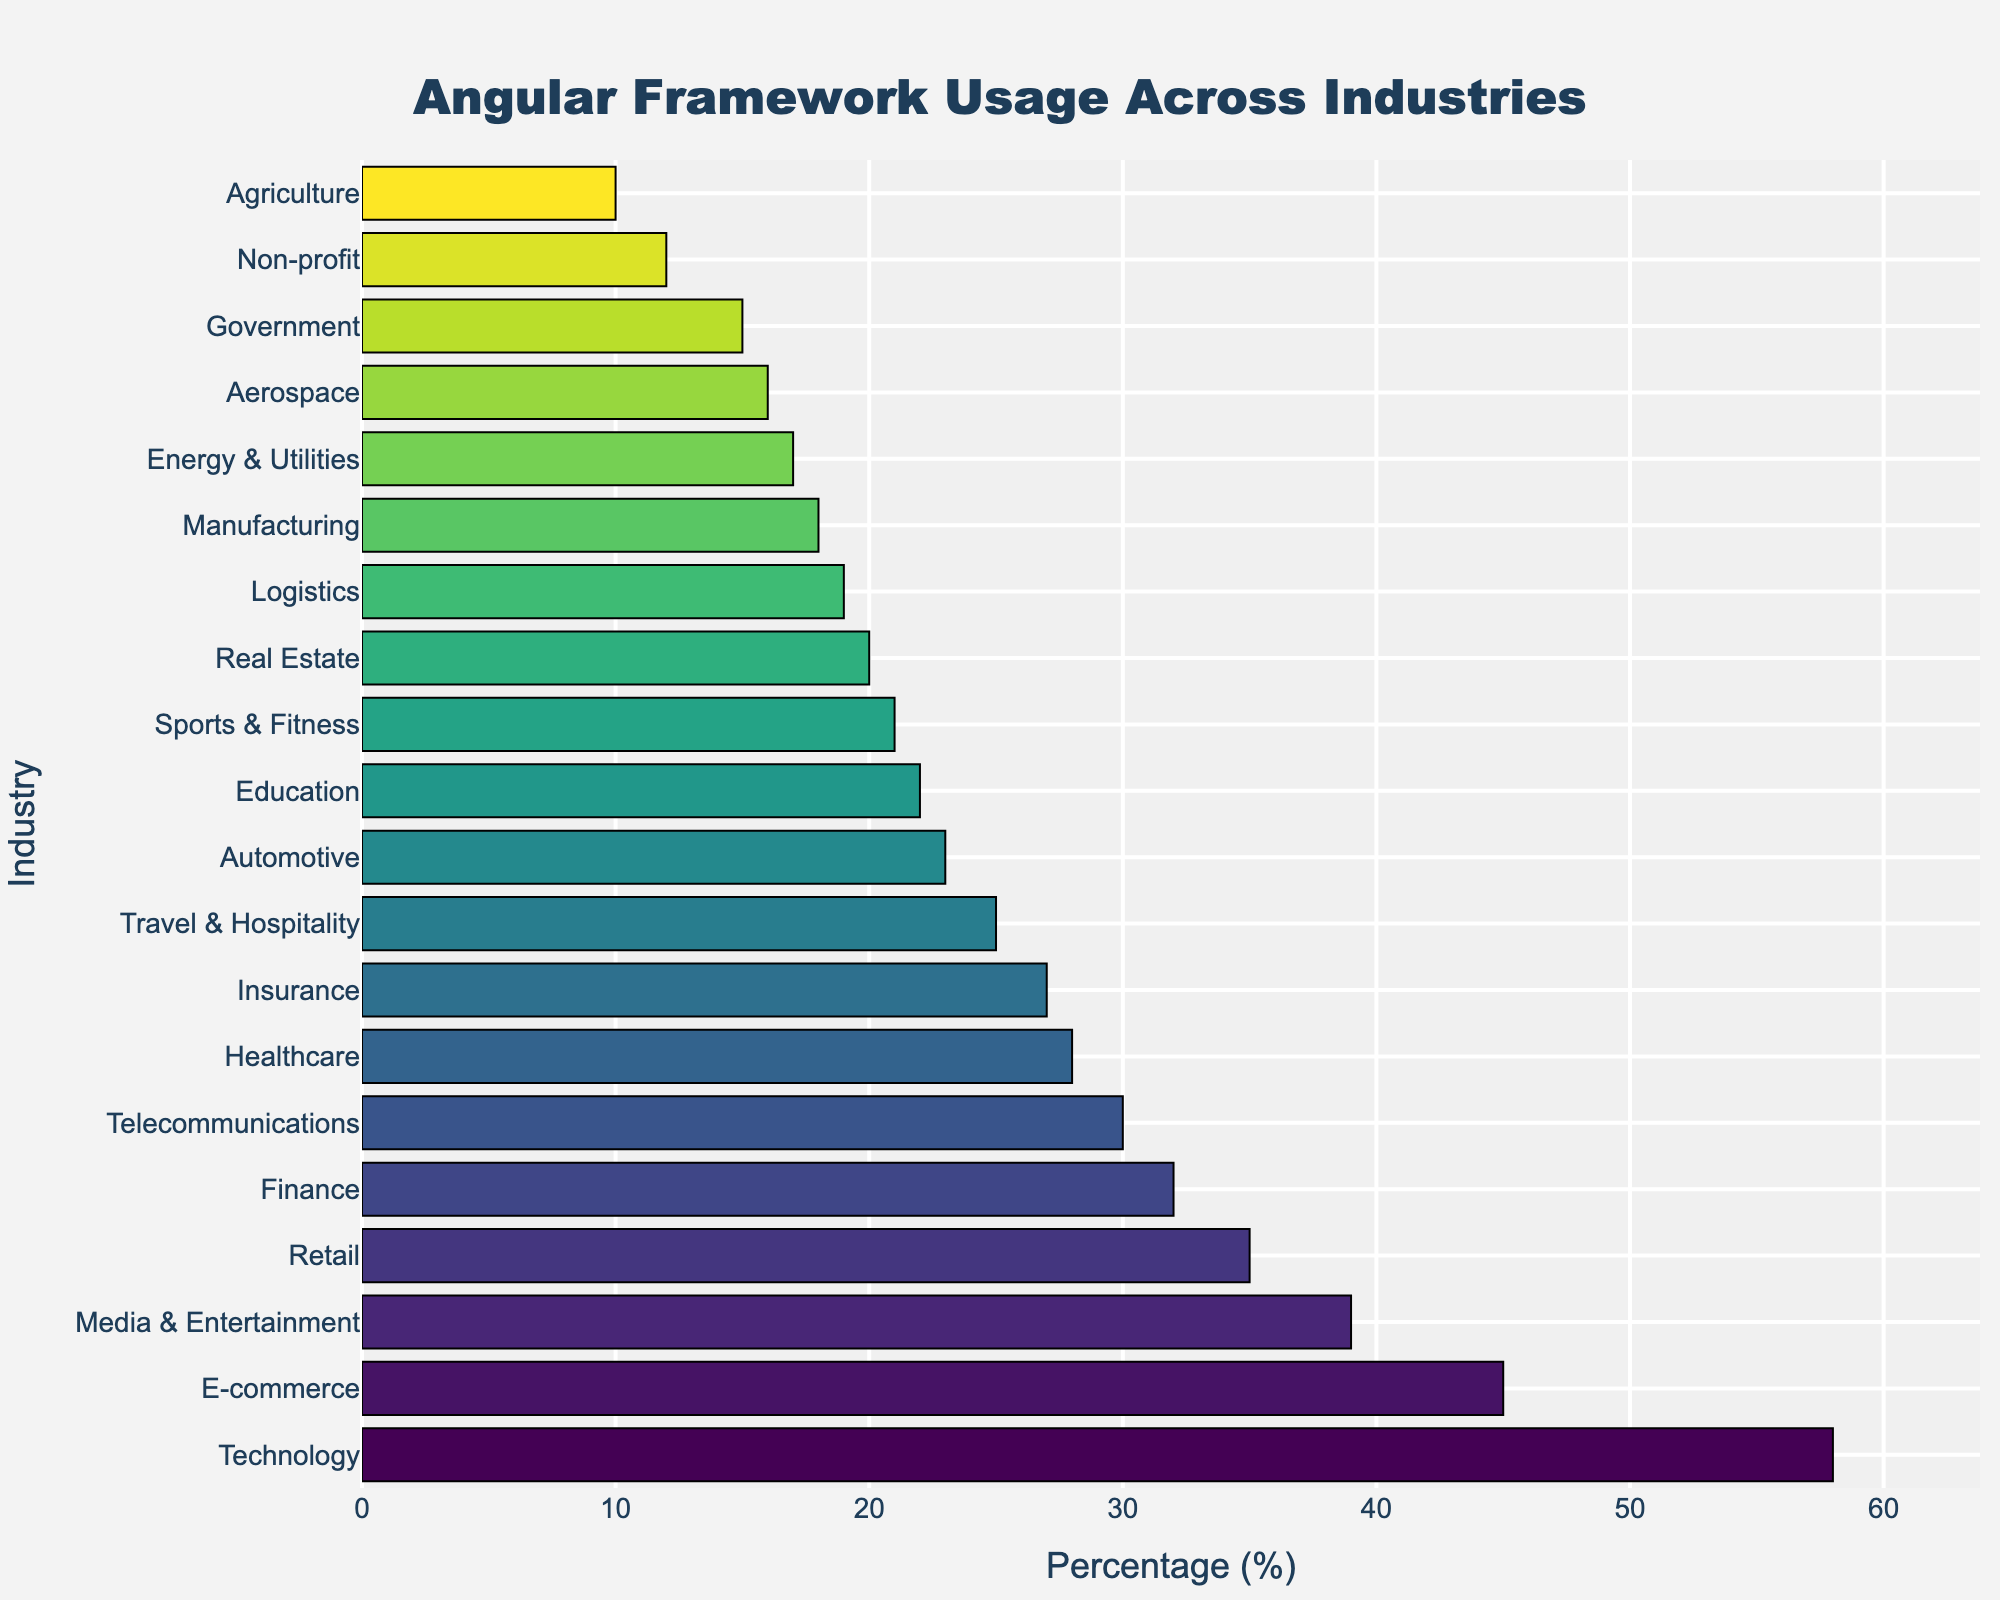Which industry has the highest usage of the Angular framework? To find the answer, locate the bar with the greatest length in the chart. The longest bar represents the industry with the highest percentage of Angular framework usage. In this case, the Technology industry has the longest bar.
Answer: Technology What is the total percentage of Angular framework usage in Finance and Healthcare? Find the percentages for Finance and Healthcare in the chart. Finance is at 32% and Healthcare is at 28%. Add these two values together: 32% + 28% = 60%.
Answer: 60% Which industry has a lower Angular framework usage, Government or Aerospace? Compare the bars representing Government and Aerospace. The bar for Government represents 15% and the bar for Aerospace represents 16%. 15% is less than 16%.
Answer: Government What’s the difference in Angular framework usage between E-commerce and Non-profit? First, find the percentages for E-commerce and Non-profit. E-commerce has 45% and Non-profit has 12%. Subtract the Non-profit percentage from the E-commerce percentage: 45% - 12% = 33%.
Answer: 33% Among Retail, Automotive, and Sports & Fitness, which industry has the median Angular framework usage? Locate the bars for Retail, Automotive, and Sports & Fitness, which have percentages of 35%, 23%, and 21% respectively. Arrange these values in ascending order: 21%, 23%, 35%. The middle value is 23%.
Answer: Automotive What is the average Angular framework usage percentage across Government, Agriculture, and Aerospace industries? Locate the bars for Government, Agriculture, and Aerospace, which have percentages of 15%, 10%, and 16% respectively. Sum these values: 15% + 10% + 16% = 41%. Divide by the number of industries: 41% / 3 ≈ 13.67%.
Answer: 13.67% Which industry has a higher Angular framework usage, Media & Entertainment or Telecommunications? Compare the bars representing Media & Entertainment and Telecommunications. Media & Entertainment has 39% and Telecommunications has 30%. 39% is higher than 30%.
Answer: Media & Entertainment What is the sum of the Angular framework usage percentages for Real Estate, Energy & Utilities, and Logistics? Find the percentages for Real Estate, Energy & Utilities, and Logistics. Real Estate has 20%, Energy & Utilities has 17%, and Logistics has 19%. Add these values together: 20% + 17% + 19% = 56%.
Answer: 56% Is the Angular framework usage percentage in Education higher or lower than in Retail? Compare the bars representing Education and Retail. Education has 22% and Retail has 35%. 22% is lower than 35%.
Answer: Lower 